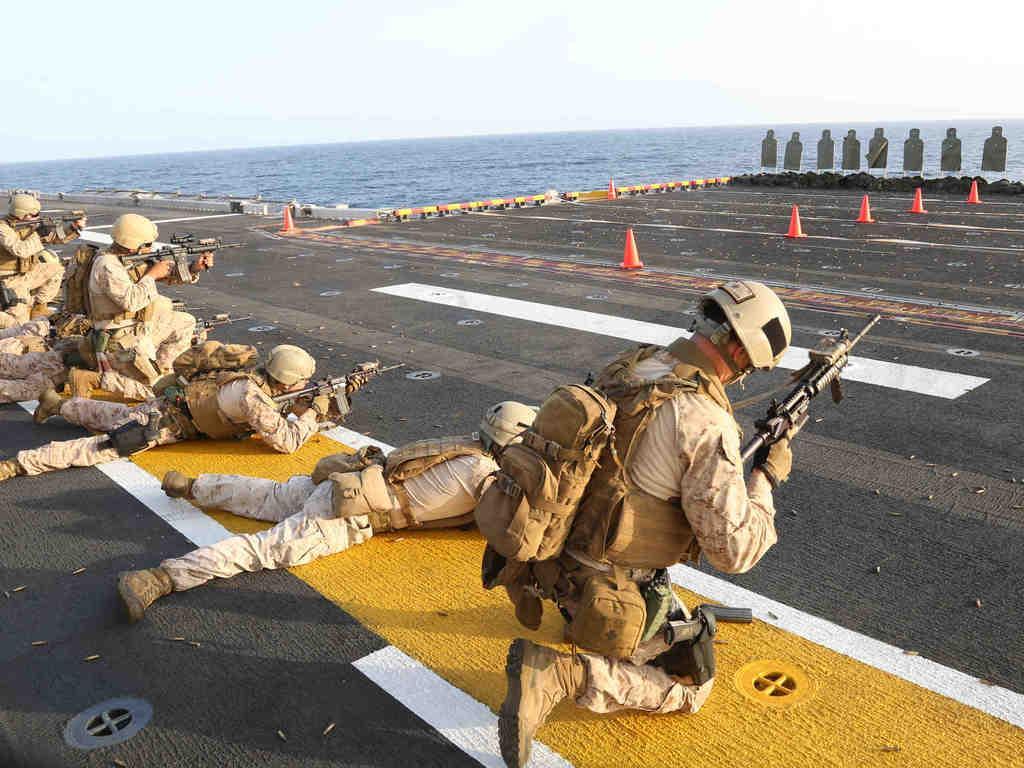How would you summarize this image in a sentence or two? This image consists of few persons wearing helmets and holding the guns. They are firing. It looks like it is clicked near the ocean. At the bottom, there is a road on which, we can see bullet shells. On the right, there are target boards. In the background, there is water. At the top, there is sky. 